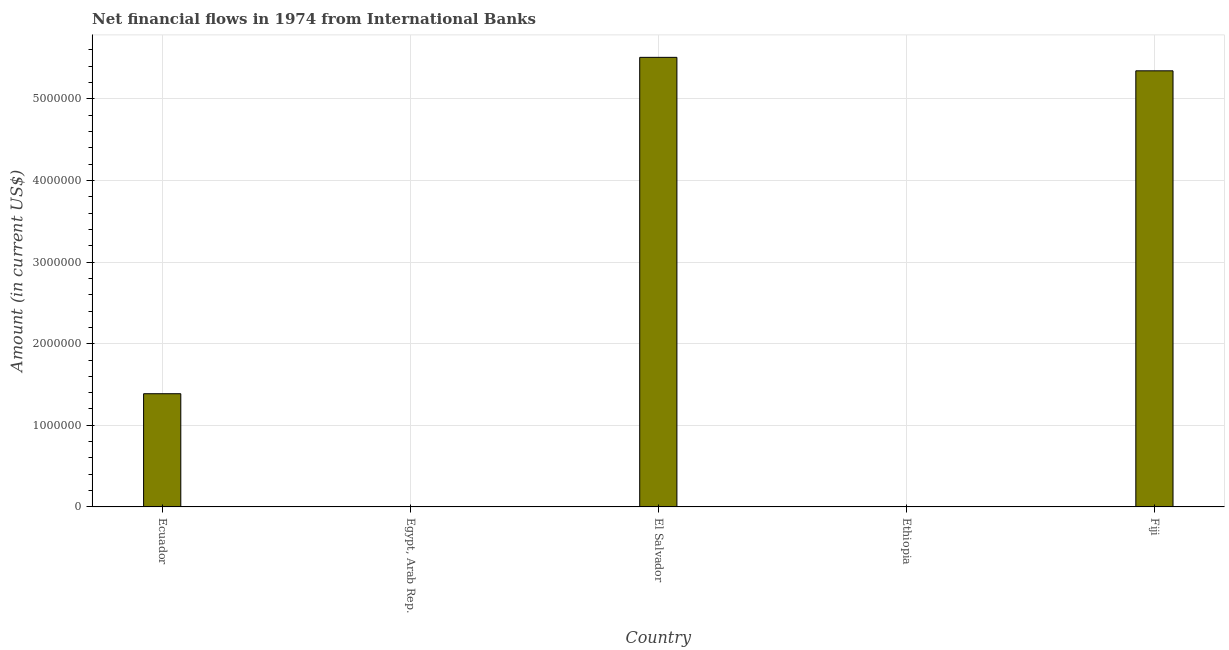Does the graph contain grids?
Your answer should be compact. Yes. What is the title of the graph?
Keep it short and to the point. Net financial flows in 1974 from International Banks. What is the label or title of the X-axis?
Keep it short and to the point. Country. What is the net financial flows from ibrd in El Salvador?
Offer a very short reply. 5.51e+06. Across all countries, what is the maximum net financial flows from ibrd?
Ensure brevity in your answer.  5.51e+06. In which country was the net financial flows from ibrd maximum?
Offer a very short reply. El Salvador. What is the sum of the net financial flows from ibrd?
Make the answer very short. 1.22e+07. What is the difference between the net financial flows from ibrd in Ecuador and El Salvador?
Ensure brevity in your answer.  -4.12e+06. What is the average net financial flows from ibrd per country?
Give a very brief answer. 2.45e+06. What is the median net financial flows from ibrd?
Make the answer very short. 1.39e+06. In how many countries, is the net financial flows from ibrd greater than 5400000 US$?
Give a very brief answer. 1. What is the ratio of the net financial flows from ibrd in Ecuador to that in Fiji?
Your answer should be compact. 0.26. Is the net financial flows from ibrd in El Salvador less than that in Fiji?
Provide a succinct answer. No. What is the difference between the highest and the second highest net financial flows from ibrd?
Your response must be concise. 1.65e+05. What is the difference between the highest and the lowest net financial flows from ibrd?
Offer a terse response. 5.51e+06. In how many countries, is the net financial flows from ibrd greater than the average net financial flows from ibrd taken over all countries?
Make the answer very short. 2. How many bars are there?
Your answer should be compact. 3. Are the values on the major ticks of Y-axis written in scientific E-notation?
Make the answer very short. No. What is the Amount (in current US$) of Ecuador?
Offer a very short reply. 1.39e+06. What is the Amount (in current US$) in Egypt, Arab Rep.?
Offer a very short reply. 0. What is the Amount (in current US$) in El Salvador?
Provide a succinct answer. 5.51e+06. What is the Amount (in current US$) in Fiji?
Your answer should be very brief. 5.34e+06. What is the difference between the Amount (in current US$) in Ecuador and El Salvador?
Provide a short and direct response. -4.12e+06. What is the difference between the Amount (in current US$) in Ecuador and Fiji?
Offer a terse response. -3.96e+06. What is the difference between the Amount (in current US$) in El Salvador and Fiji?
Ensure brevity in your answer.  1.65e+05. What is the ratio of the Amount (in current US$) in Ecuador to that in El Salvador?
Offer a terse response. 0.25. What is the ratio of the Amount (in current US$) in Ecuador to that in Fiji?
Make the answer very short. 0.26. What is the ratio of the Amount (in current US$) in El Salvador to that in Fiji?
Provide a short and direct response. 1.03. 